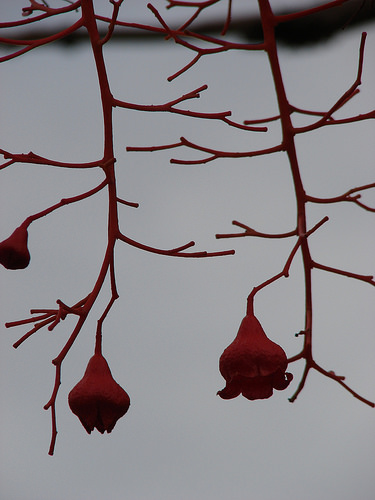<image>
Can you confirm if the flower is on the stem? No. The flower is not positioned on the stem. They may be near each other, but the flower is not supported by or resting on top of the stem. 